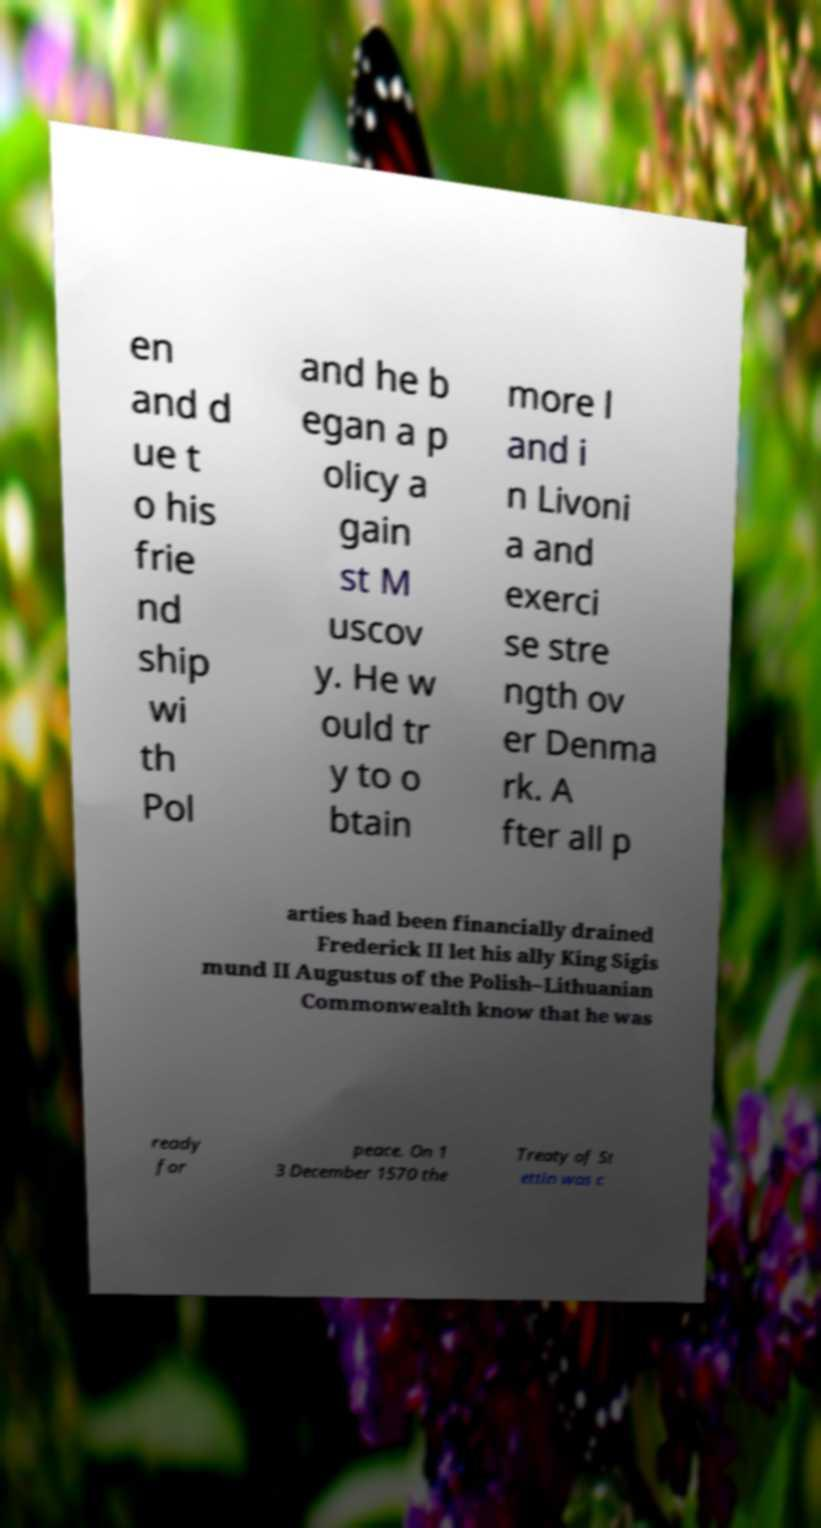What messages or text are displayed in this image? I need them in a readable, typed format. en and d ue t o his frie nd ship wi th Pol and he b egan a p olicy a gain st M uscov y. He w ould tr y to o btain more l and i n Livoni a and exerci se stre ngth ov er Denma rk. A fter all p arties had been financially drained Frederick II let his ally King Sigis mund II Augustus of the Polish–Lithuanian Commonwealth know that he was ready for peace. On 1 3 December 1570 the Treaty of St ettin was c 